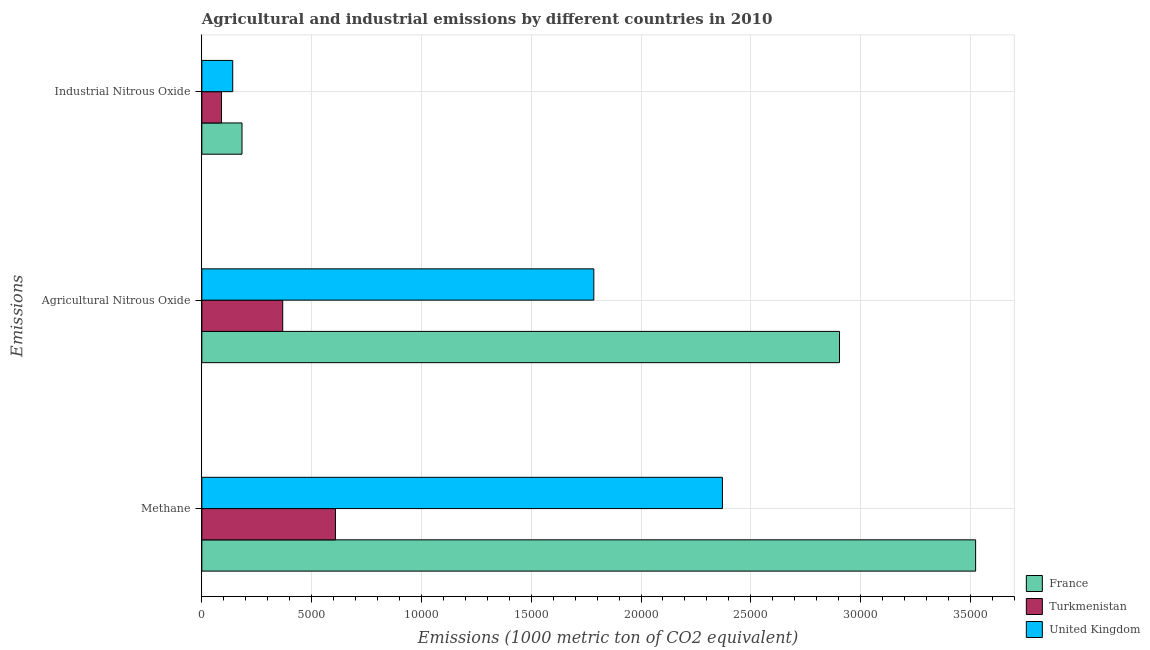How many different coloured bars are there?
Provide a short and direct response. 3. How many groups of bars are there?
Keep it short and to the point. 3. Are the number of bars on each tick of the Y-axis equal?
Make the answer very short. Yes. What is the label of the 1st group of bars from the top?
Ensure brevity in your answer.  Industrial Nitrous Oxide. What is the amount of industrial nitrous oxide emissions in France?
Provide a succinct answer. 1828.8. Across all countries, what is the maximum amount of methane emissions?
Keep it short and to the point. 3.52e+04. Across all countries, what is the minimum amount of methane emissions?
Offer a very short reply. 6084. In which country was the amount of agricultural nitrous oxide emissions minimum?
Offer a very short reply. Turkmenistan. What is the total amount of industrial nitrous oxide emissions in the graph?
Offer a terse response. 4131.5. What is the difference between the amount of agricultural nitrous oxide emissions in United Kingdom and that in Turkmenistan?
Your answer should be compact. 1.42e+04. What is the difference between the amount of methane emissions in Turkmenistan and the amount of industrial nitrous oxide emissions in France?
Your answer should be very brief. 4255.2. What is the average amount of agricultural nitrous oxide emissions per country?
Ensure brevity in your answer.  1.69e+04. What is the difference between the amount of methane emissions and amount of agricultural nitrous oxide emissions in Turkmenistan?
Keep it short and to the point. 2401.1. In how many countries, is the amount of methane emissions greater than 12000 metric ton?
Ensure brevity in your answer.  2. What is the ratio of the amount of methane emissions in Turkmenistan to that in United Kingdom?
Your response must be concise. 0.26. Is the amount of agricultural nitrous oxide emissions in United Kingdom less than that in France?
Your answer should be compact. Yes. Is the difference between the amount of industrial nitrous oxide emissions in Turkmenistan and United Kingdom greater than the difference between the amount of agricultural nitrous oxide emissions in Turkmenistan and United Kingdom?
Make the answer very short. Yes. What is the difference between the highest and the second highest amount of methane emissions?
Your response must be concise. 1.15e+04. What is the difference between the highest and the lowest amount of industrial nitrous oxide emissions?
Keep it short and to the point. 932.7. Is the sum of the amount of methane emissions in Turkmenistan and United Kingdom greater than the maximum amount of agricultural nitrous oxide emissions across all countries?
Provide a short and direct response. Yes. What does the 2nd bar from the top in Methane represents?
Provide a succinct answer. Turkmenistan. What does the 3rd bar from the bottom in Industrial Nitrous Oxide represents?
Give a very brief answer. United Kingdom. Is it the case that in every country, the sum of the amount of methane emissions and amount of agricultural nitrous oxide emissions is greater than the amount of industrial nitrous oxide emissions?
Offer a very short reply. Yes. How many bars are there?
Offer a very short reply. 9. Are the values on the major ticks of X-axis written in scientific E-notation?
Provide a short and direct response. No. Does the graph contain grids?
Make the answer very short. Yes. Where does the legend appear in the graph?
Offer a very short reply. Bottom right. How are the legend labels stacked?
Keep it short and to the point. Vertical. What is the title of the graph?
Keep it short and to the point. Agricultural and industrial emissions by different countries in 2010. What is the label or title of the X-axis?
Offer a terse response. Emissions (1000 metric ton of CO2 equivalent). What is the label or title of the Y-axis?
Provide a short and direct response. Emissions. What is the Emissions (1000 metric ton of CO2 equivalent) of France in Methane?
Give a very brief answer. 3.52e+04. What is the Emissions (1000 metric ton of CO2 equivalent) in Turkmenistan in Methane?
Make the answer very short. 6084. What is the Emissions (1000 metric ton of CO2 equivalent) in United Kingdom in Methane?
Ensure brevity in your answer.  2.37e+04. What is the Emissions (1000 metric ton of CO2 equivalent) of France in Agricultural Nitrous Oxide?
Keep it short and to the point. 2.90e+04. What is the Emissions (1000 metric ton of CO2 equivalent) in Turkmenistan in Agricultural Nitrous Oxide?
Make the answer very short. 3682.9. What is the Emissions (1000 metric ton of CO2 equivalent) in United Kingdom in Agricultural Nitrous Oxide?
Provide a short and direct response. 1.79e+04. What is the Emissions (1000 metric ton of CO2 equivalent) of France in Industrial Nitrous Oxide?
Provide a short and direct response. 1828.8. What is the Emissions (1000 metric ton of CO2 equivalent) in Turkmenistan in Industrial Nitrous Oxide?
Offer a very short reply. 896.1. What is the Emissions (1000 metric ton of CO2 equivalent) in United Kingdom in Industrial Nitrous Oxide?
Keep it short and to the point. 1406.6. Across all Emissions, what is the maximum Emissions (1000 metric ton of CO2 equivalent) in France?
Your answer should be very brief. 3.52e+04. Across all Emissions, what is the maximum Emissions (1000 metric ton of CO2 equivalent) in Turkmenistan?
Provide a succinct answer. 6084. Across all Emissions, what is the maximum Emissions (1000 metric ton of CO2 equivalent) of United Kingdom?
Your answer should be very brief. 2.37e+04. Across all Emissions, what is the minimum Emissions (1000 metric ton of CO2 equivalent) in France?
Offer a very short reply. 1828.8. Across all Emissions, what is the minimum Emissions (1000 metric ton of CO2 equivalent) in Turkmenistan?
Ensure brevity in your answer.  896.1. Across all Emissions, what is the minimum Emissions (1000 metric ton of CO2 equivalent) in United Kingdom?
Your answer should be very brief. 1406.6. What is the total Emissions (1000 metric ton of CO2 equivalent) of France in the graph?
Your answer should be very brief. 6.61e+04. What is the total Emissions (1000 metric ton of CO2 equivalent) in Turkmenistan in the graph?
Keep it short and to the point. 1.07e+04. What is the total Emissions (1000 metric ton of CO2 equivalent) of United Kingdom in the graph?
Your answer should be very brief. 4.30e+04. What is the difference between the Emissions (1000 metric ton of CO2 equivalent) of France in Methane and that in Agricultural Nitrous Oxide?
Keep it short and to the point. 6198.9. What is the difference between the Emissions (1000 metric ton of CO2 equivalent) of Turkmenistan in Methane and that in Agricultural Nitrous Oxide?
Offer a very short reply. 2401.1. What is the difference between the Emissions (1000 metric ton of CO2 equivalent) in United Kingdom in Methane and that in Agricultural Nitrous Oxide?
Your response must be concise. 5856.1. What is the difference between the Emissions (1000 metric ton of CO2 equivalent) of France in Methane and that in Industrial Nitrous Oxide?
Ensure brevity in your answer.  3.34e+04. What is the difference between the Emissions (1000 metric ton of CO2 equivalent) of Turkmenistan in Methane and that in Industrial Nitrous Oxide?
Your response must be concise. 5187.9. What is the difference between the Emissions (1000 metric ton of CO2 equivalent) of United Kingdom in Methane and that in Industrial Nitrous Oxide?
Your answer should be very brief. 2.23e+04. What is the difference between the Emissions (1000 metric ton of CO2 equivalent) of France in Agricultural Nitrous Oxide and that in Industrial Nitrous Oxide?
Your response must be concise. 2.72e+04. What is the difference between the Emissions (1000 metric ton of CO2 equivalent) of Turkmenistan in Agricultural Nitrous Oxide and that in Industrial Nitrous Oxide?
Provide a succinct answer. 2786.8. What is the difference between the Emissions (1000 metric ton of CO2 equivalent) in United Kingdom in Agricultural Nitrous Oxide and that in Industrial Nitrous Oxide?
Offer a very short reply. 1.64e+04. What is the difference between the Emissions (1000 metric ton of CO2 equivalent) of France in Methane and the Emissions (1000 metric ton of CO2 equivalent) of Turkmenistan in Agricultural Nitrous Oxide?
Offer a very short reply. 3.16e+04. What is the difference between the Emissions (1000 metric ton of CO2 equivalent) in France in Methane and the Emissions (1000 metric ton of CO2 equivalent) in United Kingdom in Agricultural Nitrous Oxide?
Give a very brief answer. 1.74e+04. What is the difference between the Emissions (1000 metric ton of CO2 equivalent) in Turkmenistan in Methane and the Emissions (1000 metric ton of CO2 equivalent) in United Kingdom in Agricultural Nitrous Oxide?
Offer a very short reply. -1.18e+04. What is the difference between the Emissions (1000 metric ton of CO2 equivalent) of France in Methane and the Emissions (1000 metric ton of CO2 equivalent) of Turkmenistan in Industrial Nitrous Oxide?
Offer a very short reply. 3.43e+04. What is the difference between the Emissions (1000 metric ton of CO2 equivalent) in France in Methane and the Emissions (1000 metric ton of CO2 equivalent) in United Kingdom in Industrial Nitrous Oxide?
Your answer should be compact. 3.38e+04. What is the difference between the Emissions (1000 metric ton of CO2 equivalent) in Turkmenistan in Methane and the Emissions (1000 metric ton of CO2 equivalent) in United Kingdom in Industrial Nitrous Oxide?
Your response must be concise. 4677.4. What is the difference between the Emissions (1000 metric ton of CO2 equivalent) of France in Agricultural Nitrous Oxide and the Emissions (1000 metric ton of CO2 equivalent) of Turkmenistan in Industrial Nitrous Oxide?
Ensure brevity in your answer.  2.81e+04. What is the difference between the Emissions (1000 metric ton of CO2 equivalent) of France in Agricultural Nitrous Oxide and the Emissions (1000 metric ton of CO2 equivalent) of United Kingdom in Industrial Nitrous Oxide?
Offer a very short reply. 2.76e+04. What is the difference between the Emissions (1000 metric ton of CO2 equivalent) of Turkmenistan in Agricultural Nitrous Oxide and the Emissions (1000 metric ton of CO2 equivalent) of United Kingdom in Industrial Nitrous Oxide?
Provide a succinct answer. 2276.3. What is the average Emissions (1000 metric ton of CO2 equivalent) of France per Emissions?
Offer a very short reply. 2.20e+04. What is the average Emissions (1000 metric ton of CO2 equivalent) of Turkmenistan per Emissions?
Offer a very short reply. 3554.33. What is the average Emissions (1000 metric ton of CO2 equivalent) in United Kingdom per Emissions?
Offer a very short reply. 1.43e+04. What is the difference between the Emissions (1000 metric ton of CO2 equivalent) in France and Emissions (1000 metric ton of CO2 equivalent) in Turkmenistan in Methane?
Offer a terse response. 2.92e+04. What is the difference between the Emissions (1000 metric ton of CO2 equivalent) of France and Emissions (1000 metric ton of CO2 equivalent) of United Kingdom in Methane?
Your answer should be compact. 1.15e+04. What is the difference between the Emissions (1000 metric ton of CO2 equivalent) in Turkmenistan and Emissions (1000 metric ton of CO2 equivalent) in United Kingdom in Methane?
Provide a succinct answer. -1.76e+04. What is the difference between the Emissions (1000 metric ton of CO2 equivalent) in France and Emissions (1000 metric ton of CO2 equivalent) in Turkmenistan in Agricultural Nitrous Oxide?
Keep it short and to the point. 2.54e+04. What is the difference between the Emissions (1000 metric ton of CO2 equivalent) in France and Emissions (1000 metric ton of CO2 equivalent) in United Kingdom in Agricultural Nitrous Oxide?
Keep it short and to the point. 1.12e+04. What is the difference between the Emissions (1000 metric ton of CO2 equivalent) of Turkmenistan and Emissions (1000 metric ton of CO2 equivalent) of United Kingdom in Agricultural Nitrous Oxide?
Ensure brevity in your answer.  -1.42e+04. What is the difference between the Emissions (1000 metric ton of CO2 equivalent) in France and Emissions (1000 metric ton of CO2 equivalent) in Turkmenistan in Industrial Nitrous Oxide?
Your answer should be very brief. 932.7. What is the difference between the Emissions (1000 metric ton of CO2 equivalent) in France and Emissions (1000 metric ton of CO2 equivalent) in United Kingdom in Industrial Nitrous Oxide?
Provide a succinct answer. 422.2. What is the difference between the Emissions (1000 metric ton of CO2 equivalent) of Turkmenistan and Emissions (1000 metric ton of CO2 equivalent) of United Kingdom in Industrial Nitrous Oxide?
Provide a succinct answer. -510.5. What is the ratio of the Emissions (1000 metric ton of CO2 equivalent) in France in Methane to that in Agricultural Nitrous Oxide?
Provide a succinct answer. 1.21. What is the ratio of the Emissions (1000 metric ton of CO2 equivalent) of Turkmenistan in Methane to that in Agricultural Nitrous Oxide?
Give a very brief answer. 1.65. What is the ratio of the Emissions (1000 metric ton of CO2 equivalent) in United Kingdom in Methane to that in Agricultural Nitrous Oxide?
Give a very brief answer. 1.33. What is the ratio of the Emissions (1000 metric ton of CO2 equivalent) of France in Methane to that in Industrial Nitrous Oxide?
Offer a very short reply. 19.27. What is the ratio of the Emissions (1000 metric ton of CO2 equivalent) in Turkmenistan in Methane to that in Industrial Nitrous Oxide?
Keep it short and to the point. 6.79. What is the ratio of the Emissions (1000 metric ton of CO2 equivalent) in United Kingdom in Methane to that in Industrial Nitrous Oxide?
Ensure brevity in your answer.  16.85. What is the ratio of the Emissions (1000 metric ton of CO2 equivalent) of France in Agricultural Nitrous Oxide to that in Industrial Nitrous Oxide?
Offer a terse response. 15.88. What is the ratio of the Emissions (1000 metric ton of CO2 equivalent) of Turkmenistan in Agricultural Nitrous Oxide to that in Industrial Nitrous Oxide?
Your response must be concise. 4.11. What is the ratio of the Emissions (1000 metric ton of CO2 equivalent) in United Kingdom in Agricultural Nitrous Oxide to that in Industrial Nitrous Oxide?
Provide a short and direct response. 12.69. What is the difference between the highest and the second highest Emissions (1000 metric ton of CO2 equivalent) of France?
Provide a succinct answer. 6198.9. What is the difference between the highest and the second highest Emissions (1000 metric ton of CO2 equivalent) of Turkmenistan?
Your answer should be compact. 2401.1. What is the difference between the highest and the second highest Emissions (1000 metric ton of CO2 equivalent) in United Kingdom?
Keep it short and to the point. 5856.1. What is the difference between the highest and the lowest Emissions (1000 metric ton of CO2 equivalent) in France?
Ensure brevity in your answer.  3.34e+04. What is the difference between the highest and the lowest Emissions (1000 metric ton of CO2 equivalent) in Turkmenistan?
Make the answer very short. 5187.9. What is the difference between the highest and the lowest Emissions (1000 metric ton of CO2 equivalent) in United Kingdom?
Your response must be concise. 2.23e+04. 